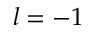<formula> <loc_0><loc_0><loc_500><loc_500>l = - 1</formula> 